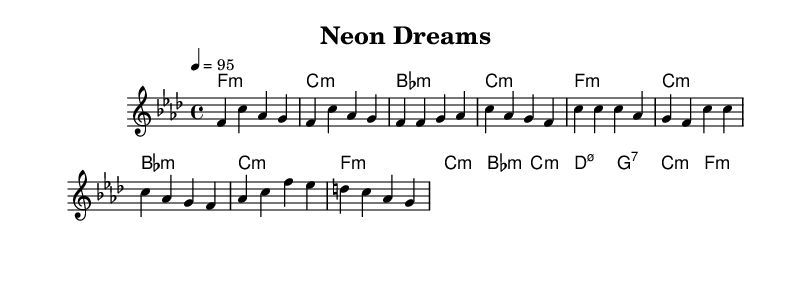what is the key signature of this music? The key signature is F minor, which has four flats (B, E, A, D). This can be determined from the key indicated in the global section of the code.
Answer: F minor what is the time signature of this music? The time signature is 4/4, which means there are four beats in each measure and the quarter note receives one beat. This is found in the global section of the code.
Answer: 4/4 what is the tempo of this music? The tempo is 95 beats per minute, as specified in the global section of the code. This information indicates how fast the music should be played.
Answer: 95 how many measures are in the chorus? There are four measures in the chorus, as shown in the melody section where it distinctly repeats two lines each containing two measures. Counting these gives a total of four.
Answer: 4 what is the first chord played in the intro? The first chord played in the intro is F minor, which is indicated at the start of the harmonies section in the chord mode.
Answer: F minor which section contains a bridge? The section labeled "Bridge" in the sheet music indicates the section that contains the bridge, which is a common part of song structure in rhythm and blues. The bridge helps to transition and contrast from the chorus and verse sections.
Answer: Bridge what type of seventh chord is used at the bridge? The type of seventh chord used at the bridge is D minor 7 flat 5 as indicated in the harmonies section with the specific notation. This indicates a specific diminished quality that adds tension.
Answer: D minor 7 flat 5 